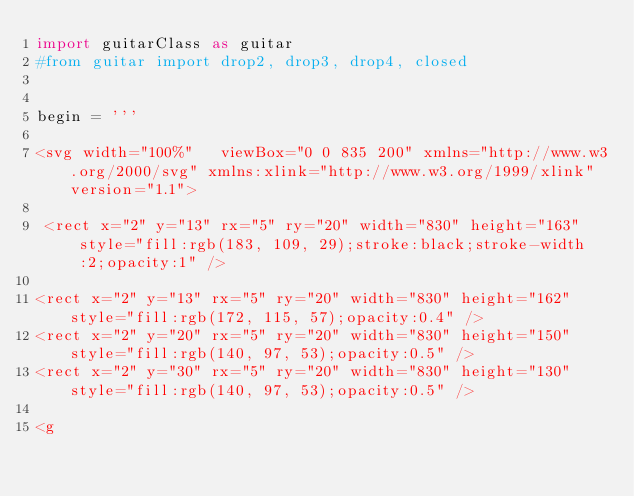<code> <loc_0><loc_0><loc_500><loc_500><_Python_>import guitarClass as guitar
#from guitar import drop2, drop3, drop4, closed


begin = '''

<svg width="100%"   viewBox="0 0 835 200" xmlns="http://www.w3.org/2000/svg" xmlns:xlink="http://www.w3.org/1999/xlink" version="1.1">

 <rect x="2" y="13" rx="5" ry="20" width="830" height="163" style="fill:rgb(183, 109, 29);stroke:black;stroke-width:2;opacity:1" />

<rect x="2" y="13" rx="5" ry="20" width="830" height="162" style="fill:rgb(172, 115, 57);opacity:0.4" />
<rect x="2" y="20" rx="5" ry="20" width="830" height="150" style="fill:rgb(140, 97, 53);opacity:0.5" />
<rect x="2" y="30" rx="5" ry="20" width="830" height="130" style="fill:rgb(140, 97, 53);opacity:0.5" />

<g</code> 